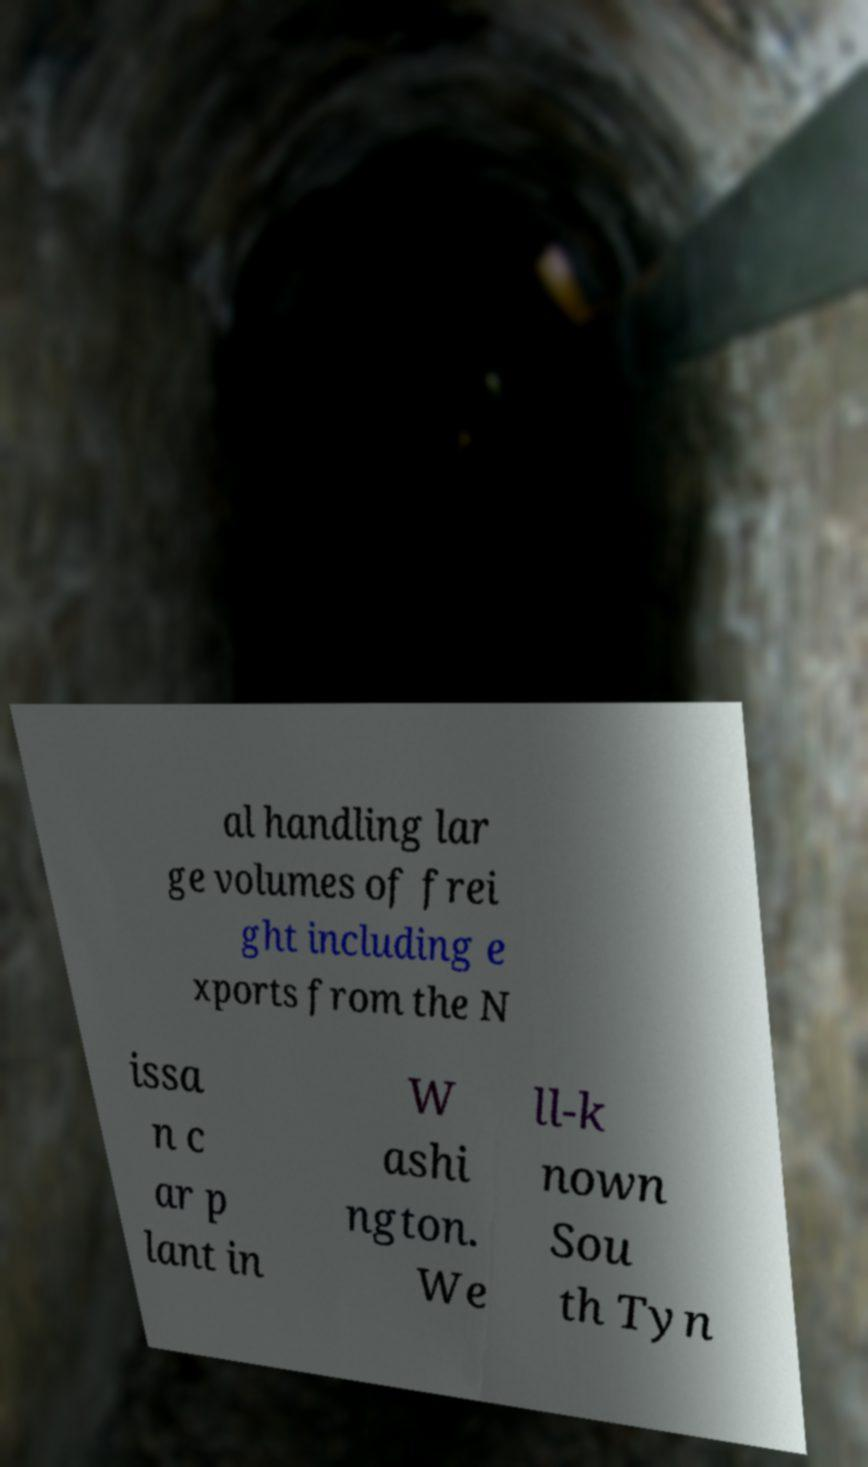For documentation purposes, I need the text within this image transcribed. Could you provide that? al handling lar ge volumes of frei ght including e xports from the N issa n c ar p lant in W ashi ngton. We ll-k nown Sou th Tyn 